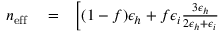<formula> <loc_0><loc_0><loc_500><loc_500>\begin{array} { r l r } { n _ { e f f } } & = } & { \left [ ( 1 - f ) \epsilon _ { h } + f \epsilon _ { i } \frac { 3 \epsilon _ { h } } { 2 \epsilon _ { h } + \epsilon _ { i } } } \end{array}</formula> 